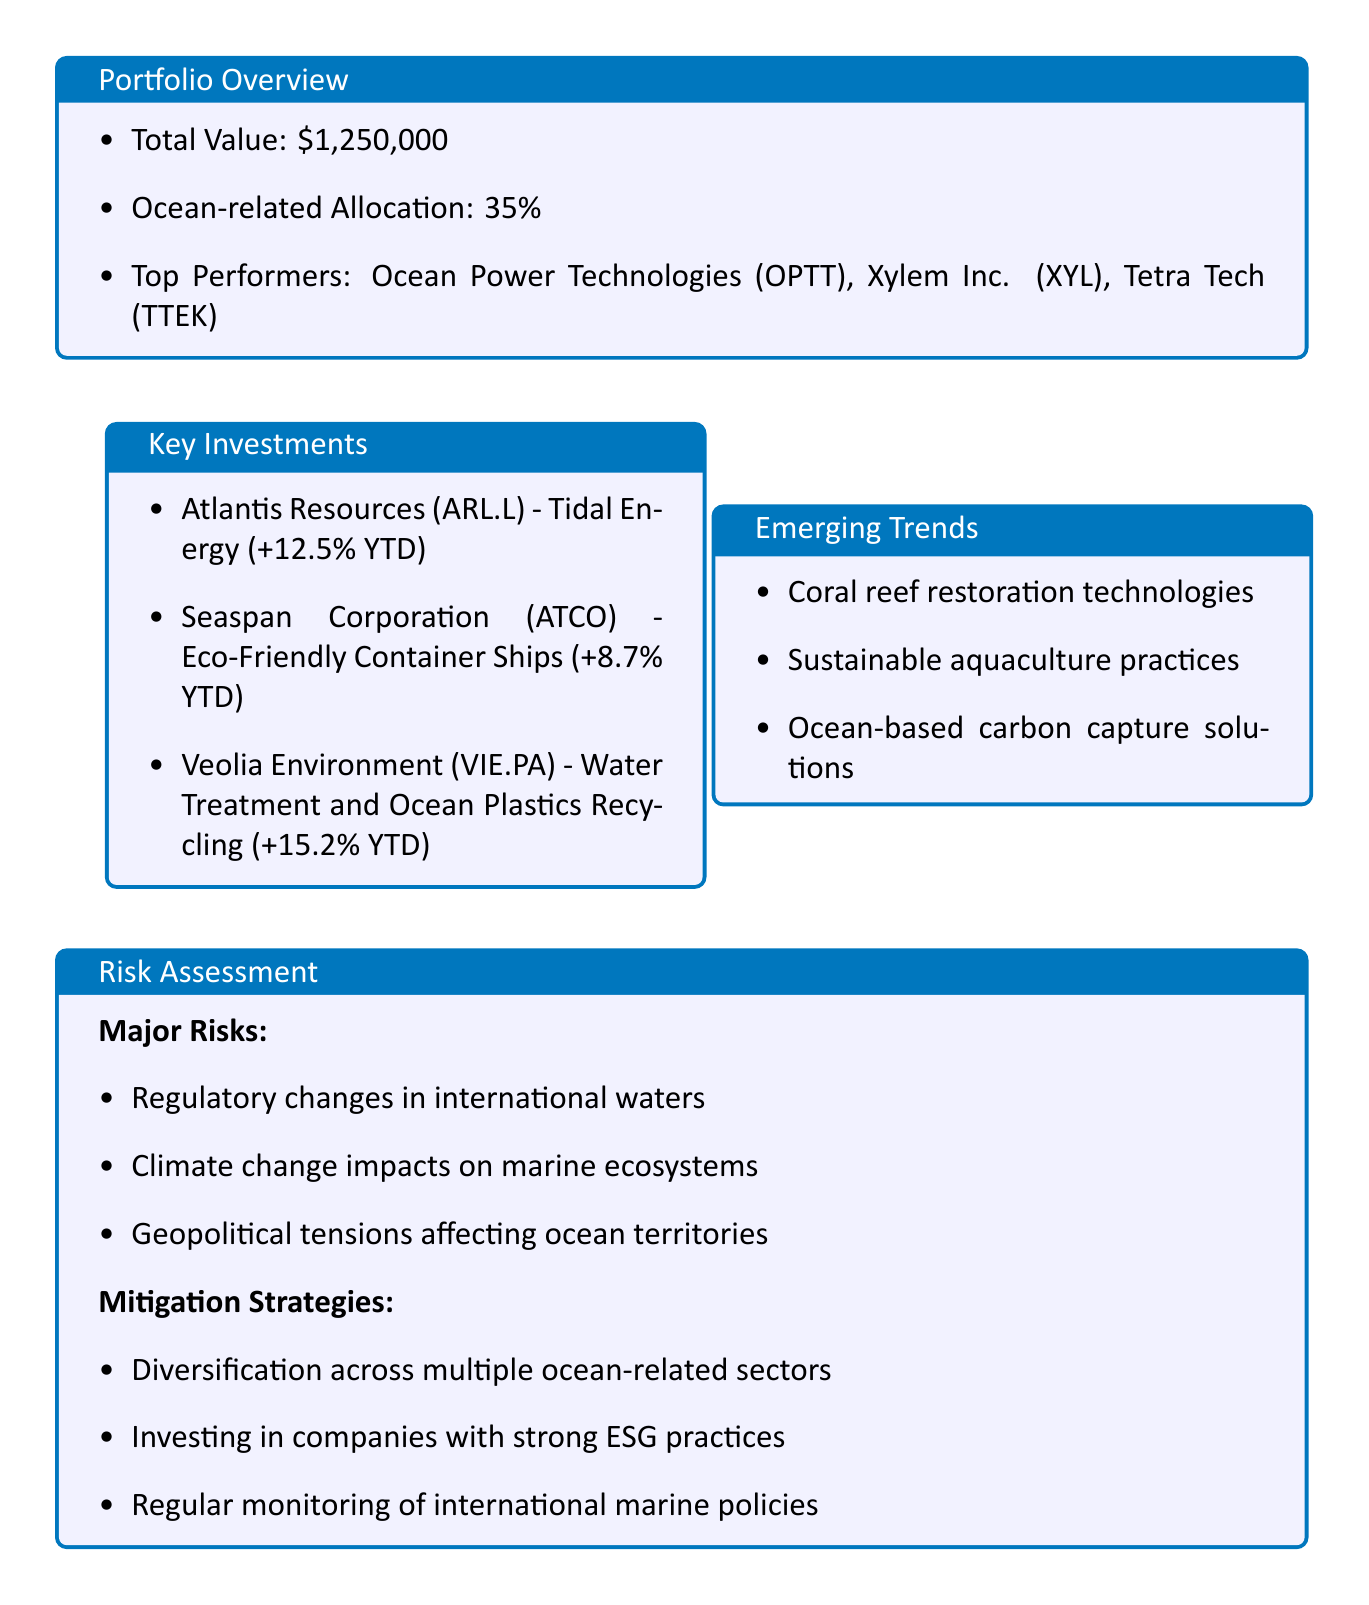What is the total value of the portfolio? The total value of the portfolio is indicated in the document under the portfolio overview section as $1,250,000.
Answer: $1,250,000 Which company has the highest year-to-date performance? Among the key investments listed, Veolia Environment (VIE.PA) shows the highest year-to-date performance at +15.2%.
Answer: Veolia Environment (VIE.PA) What percentage of the portfolio is allocated to ocean-related businesses? The allocation to ocean-related businesses is specified in the overview section as 35%.
Answer: 35% What major risks are identified in the risk assessment? Major risks mentioned include regulatory changes in international waters, climate change impacts on marine ecosystems, and geopolitical tensions affecting ocean territories.
Answer: Regulatory changes in international waters, climate change impacts on marine ecosystems, geopolitical tensions affecting ocean territories What action items are suggested for improvement? The action items listed include researching companies developing advanced scuba gear with minimal environmental impact and exploring investment opportunities in marine protected area management technologies.
Answer: Research companies developing advanced scuba gear with minimal environmental impact; explore investment opportunities in marine protected area management technologies Which area should investors watch for future developments? Areas to watch include developments in ocean energy harvesting, advancements in marine conservation tech, and innovations in plastic-free packaging for marine products.
Answer: Developments in ocean energy harvesting, advancements in marine conservation tech, innovations in plastic-free packaging for marine products What is the performance of Seaspan Corporation? The performance of Seaspan Corporation (ATCO) is given as +8.7% year-to-date in the key investments section.
Answer: +8.7% YTD What emerging trends are mentioned in the report? Emerging trends consist of coral reef restoration technologies, sustainable aquaculture practices, and ocean-based carbon capture solutions.
Answer: Coral reef restoration technologies, sustainable aquaculture practices, ocean-based carbon capture solutions 